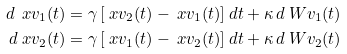Convert formula to latex. <formula><loc_0><loc_0><loc_500><loc_500>d \ x v _ { 1 } ( t ) & = \gamma \left [ \ x v _ { 2 } ( t ) - \ x v _ { 1 } ( t ) \right ] d t + \kappa \, d \ W v _ { 1 } ( t ) \\ d \ x v _ { 2 } ( t ) & = \gamma \left [ \ x v _ { 1 } ( t ) - \ x v _ { 2 } ( t ) \right ] d t + \kappa \, d \ W v _ { 2 } ( t )</formula> 